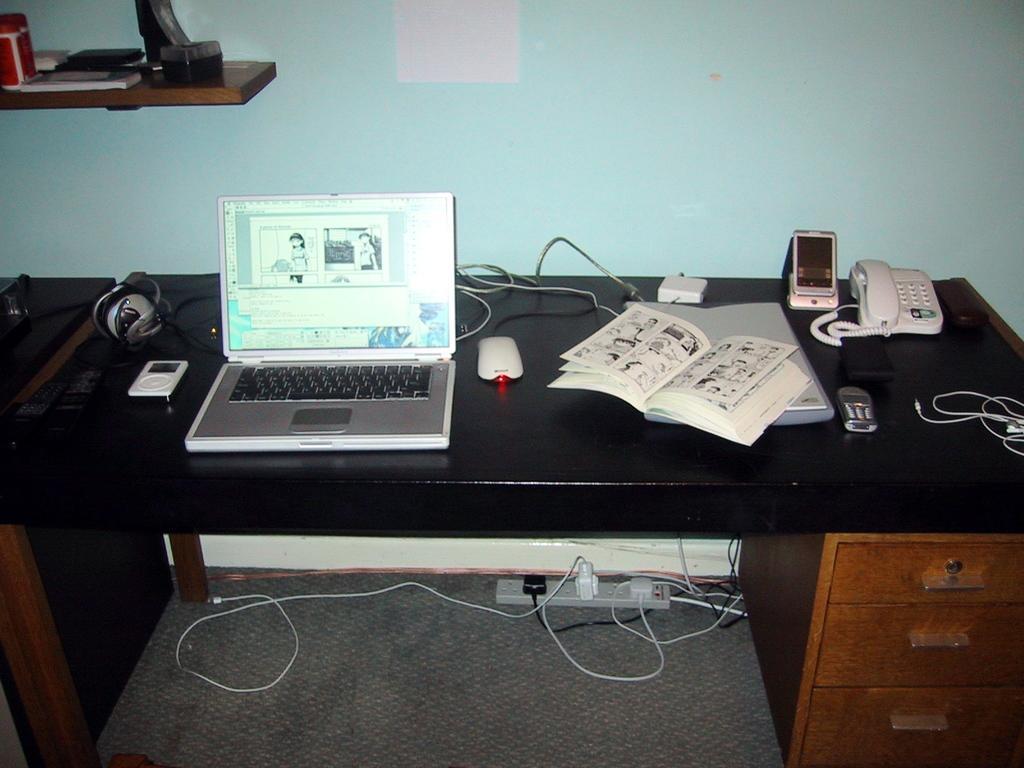Can you describe this image briefly? In this picture we can see table and on table we have laptop, mouse, wires, books, telephone, mobile, remote and under this we have a switch board, racks and in background we can see wall and wooden plank. 